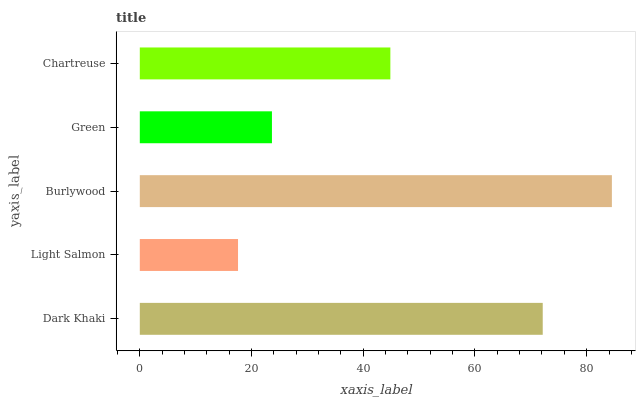Is Light Salmon the minimum?
Answer yes or no. Yes. Is Burlywood the maximum?
Answer yes or no. Yes. Is Burlywood the minimum?
Answer yes or no. No. Is Light Salmon the maximum?
Answer yes or no. No. Is Burlywood greater than Light Salmon?
Answer yes or no. Yes. Is Light Salmon less than Burlywood?
Answer yes or no. Yes. Is Light Salmon greater than Burlywood?
Answer yes or no. No. Is Burlywood less than Light Salmon?
Answer yes or no. No. Is Chartreuse the high median?
Answer yes or no. Yes. Is Chartreuse the low median?
Answer yes or no. Yes. Is Light Salmon the high median?
Answer yes or no. No. Is Light Salmon the low median?
Answer yes or no. No. 